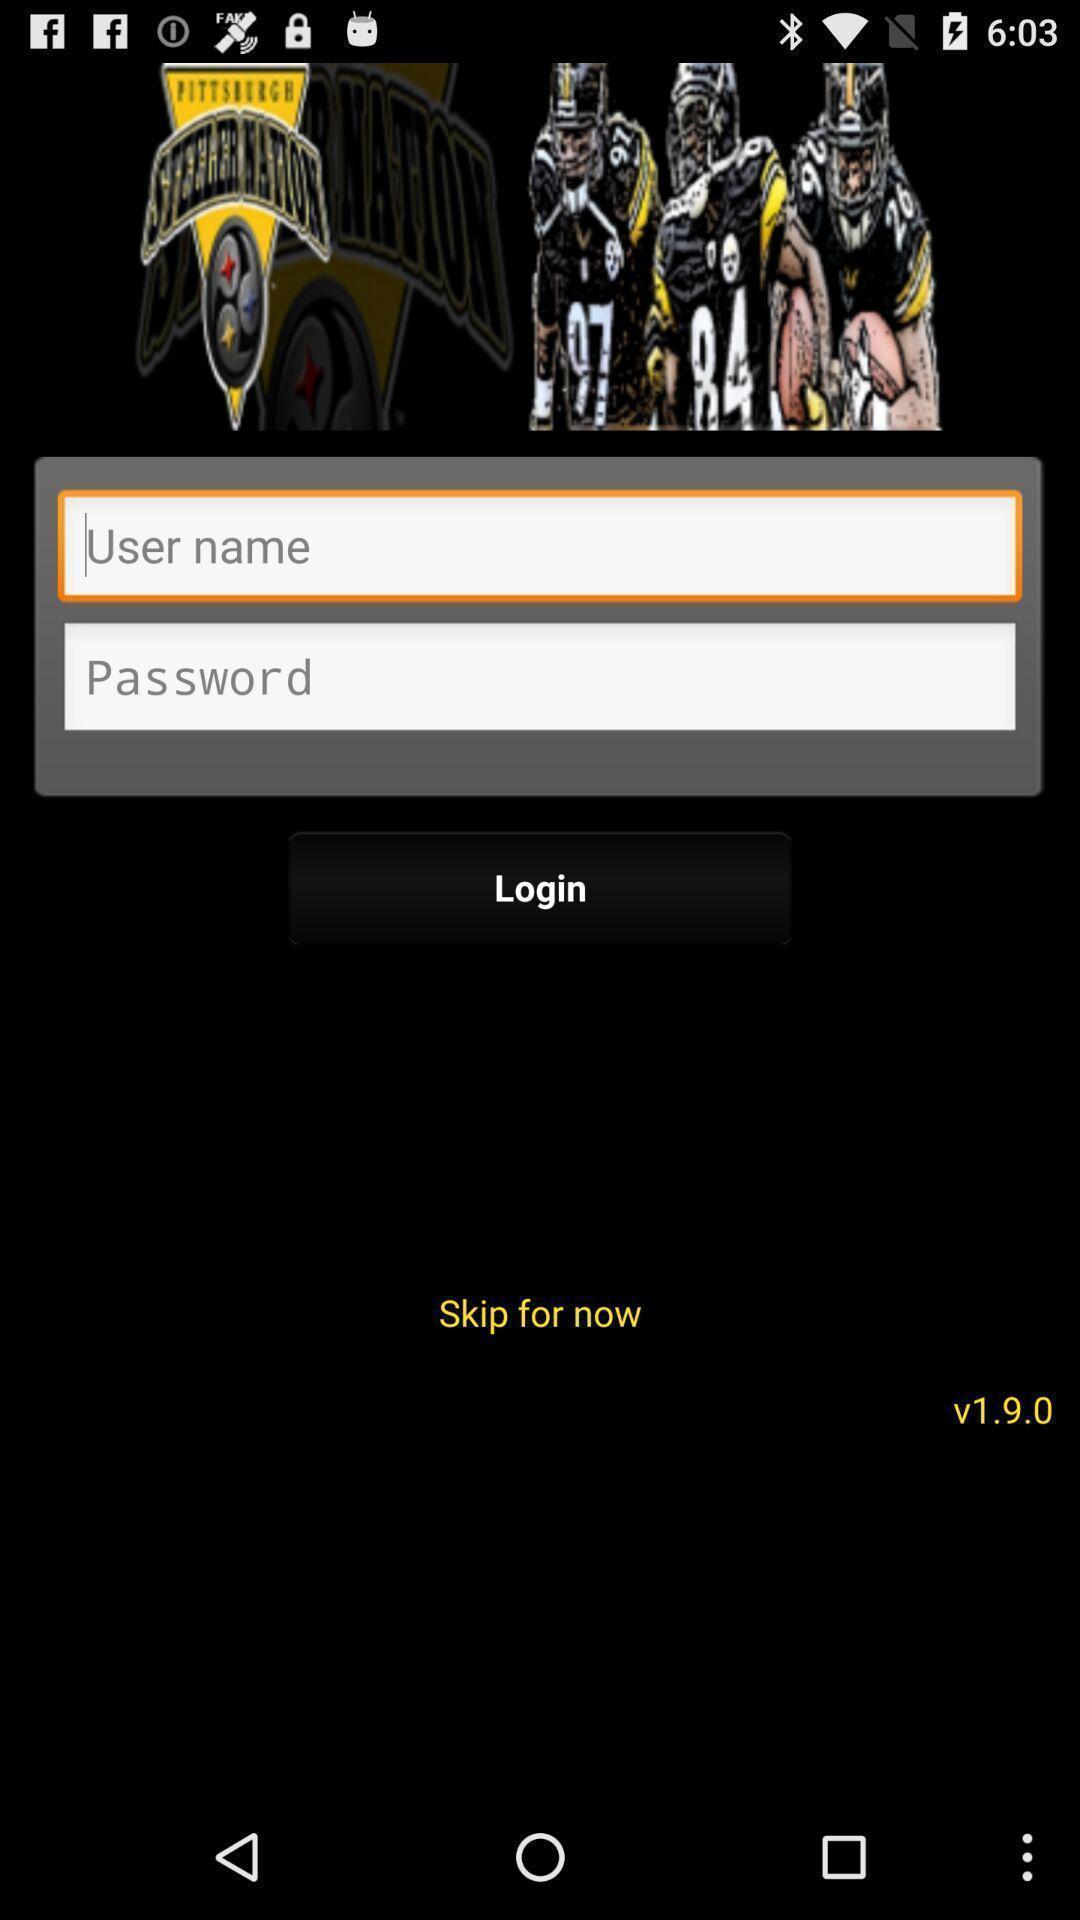Provide a description of this screenshot. Welcome page with login options in a sports team app. 